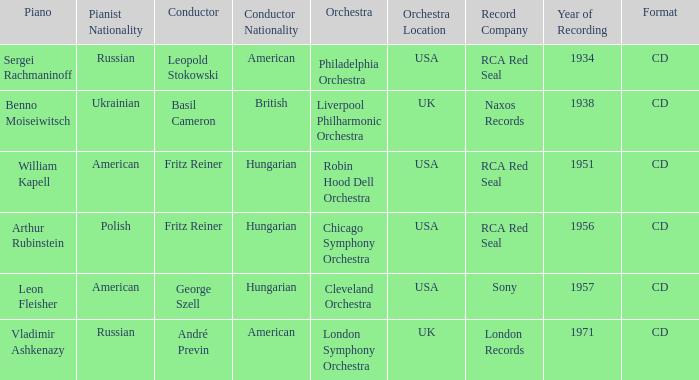Which orchestra has a recording year of 1951? Robin Hood Dell Orchestra. 